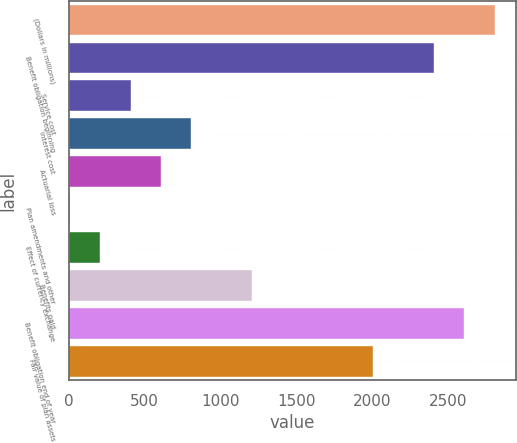Convert chart to OTSL. <chart><loc_0><loc_0><loc_500><loc_500><bar_chart><fcel>(Dollars in millions)<fcel>Benefit obligation beginning<fcel>Service cost<fcel>Interest cost<fcel>Actuarial loss<fcel>Plan amendments and other<fcel>Effect of currency exchange<fcel>Benefits paid<fcel>Benefit obligation end of year<fcel>Fair value of plan assets<nl><fcel>2804.2<fcel>2404.6<fcel>406.6<fcel>806.2<fcel>606.4<fcel>7<fcel>206.8<fcel>1205.8<fcel>2604.4<fcel>2005<nl></chart> 